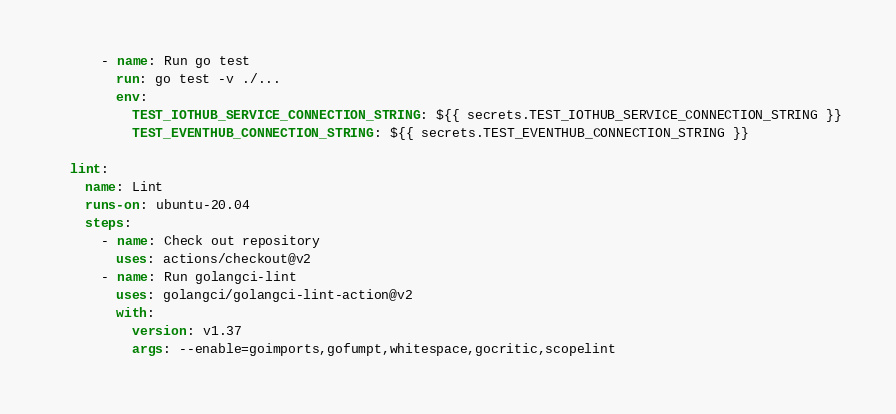Convert code to text. <code><loc_0><loc_0><loc_500><loc_500><_YAML_>      - name: Run go test
        run: go test -v ./...
        env:
          TEST_IOTHUB_SERVICE_CONNECTION_STRING: ${{ secrets.TEST_IOTHUB_SERVICE_CONNECTION_STRING }}
          TEST_EVENTHUB_CONNECTION_STRING: ${{ secrets.TEST_EVENTHUB_CONNECTION_STRING }}

  lint:
    name: Lint
    runs-on: ubuntu-20.04
    steps:
      - name: Check out repository
        uses: actions/checkout@v2
      - name: Run golangci-lint
        uses: golangci/golangci-lint-action@v2
        with:
          version: v1.37
          args: --enable=goimports,gofumpt,whitespace,gocritic,scopelint
</code> 